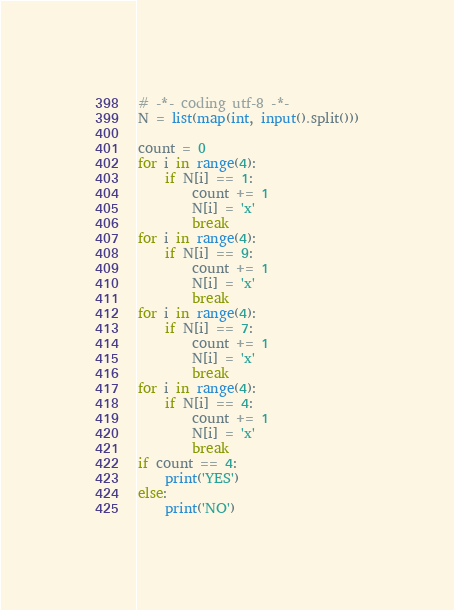<code> <loc_0><loc_0><loc_500><loc_500><_Python_># -*- coding utf-8 -*-
N = list(map(int, input().split()))

count = 0
for i in range(4):
    if N[i] == 1:
        count += 1
        N[i] = 'x'
        break
for i in range(4):
    if N[i] == 9:
        count += 1
        N[i] = 'x'
        break
for i in range(4):
    if N[i] == 7:
        count += 1
        N[i] = 'x'
        break
for i in range(4):
    if N[i] == 4:
        count += 1
        N[i] = 'x'
        break
if count == 4:
    print('YES')
else:
    print('NO')
</code> 